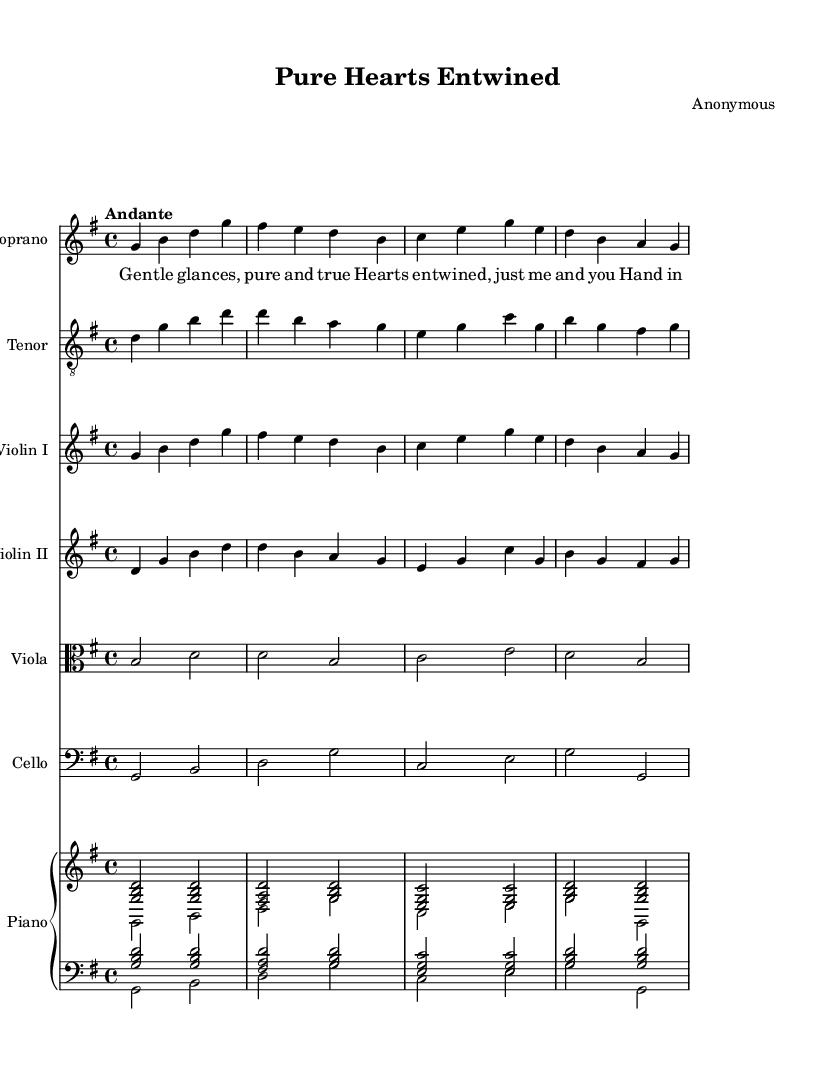What is the key signature of this music? The key signature is G major, which has one sharp (F#). You can identify it from the signature indicated at the beginning of the staff.
Answer: G major What is the time signature of this music? The time signature is 4/4, which means there are four beats in each measure and a quarter note receives one beat. This can be found at the beginning of the piece right after the key signature.
Answer: 4/4 What is the tempo marking of this music? The tempo marking is "Andante," which indicates a moderately slow pace. This is stated at the beginning of the score before the music starts.
Answer: Andante Which instrument plays the melody along with the soprano? The tenor plays the melody along with the soprano in a duet. You can see that the soprano and tenor parts are both labeled in their respective staves and contain similar rhythmic patterns.
Answer: Tenor How many measures does the soprano part consist of? The soprano part consists of four measures. By counting the vertical lines (barlines), you can determine the number of measures present in the staff.
Answer: Four measures What theme does the lyrics of this opera convey? The lyrics convey a theme of pure and chaste love, emphasizing gentle glances and the bond of hearts entwined. This theme is explicitly reflected in the words of the verse.
Answer: Pure love Which instruments are included in the ensemble? The ensemble includes violins, viola, cello, piano, soprano, and tenor. You can find these instruments listed in the score, each with its own staff designated.
Answer: Violins, viola, cello, piano, soprano, tenor 